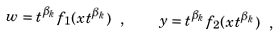<formula> <loc_0><loc_0><loc_500><loc_500>w = t ^ { \beta _ { k } } f _ { 1 } ( x t ^ { \beta _ { k } } ) \ , \quad y = t ^ { \beta _ { k } } f _ { 2 } ( x t ^ { \beta _ { k } } ) \ ,</formula> 